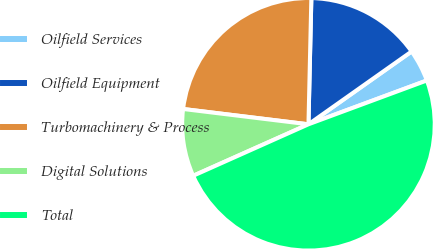Convert chart to OTSL. <chart><loc_0><loc_0><loc_500><loc_500><pie_chart><fcel>Oilfield Services<fcel>Oilfield Equipment<fcel>Turbomachinery & Process<fcel>Digital Solutions<fcel>Total<nl><fcel>4.14%<fcel>14.85%<fcel>23.43%<fcel>8.62%<fcel>48.96%<nl></chart> 